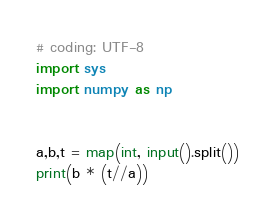Convert code to text. <code><loc_0><loc_0><loc_500><loc_500><_Python_># coding: UTF-8
import sys
import numpy as np


a,b,t = map(int, input().split())
print(b * (t//a))</code> 